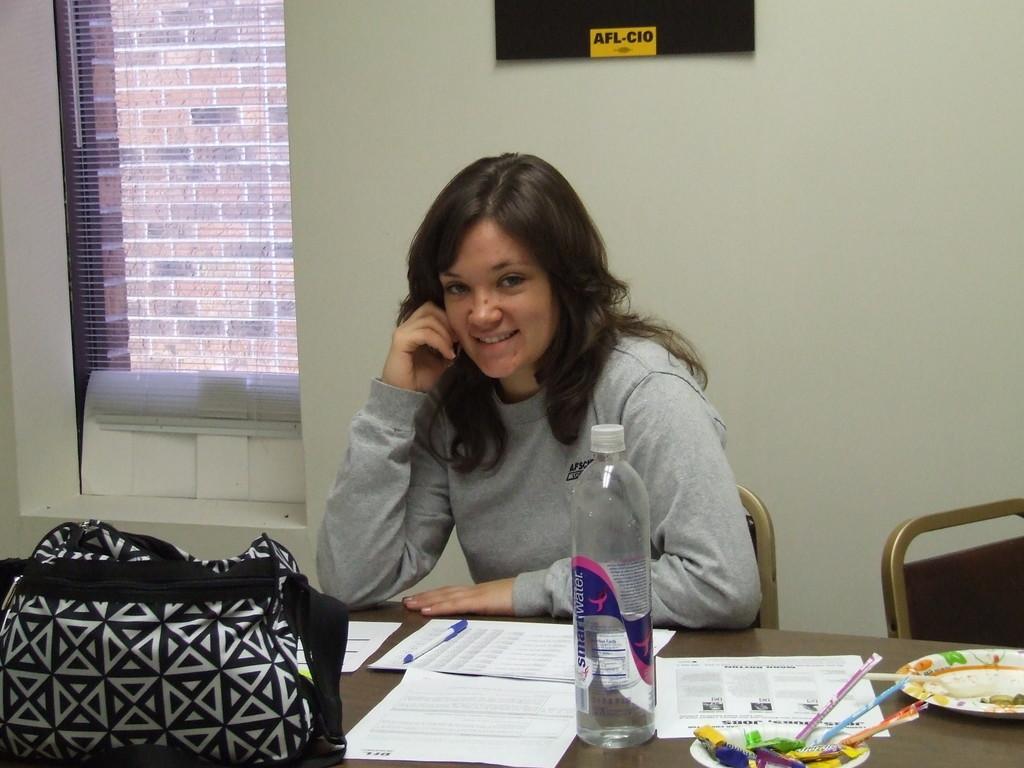How would you summarize this image in a sentence or two? In the middle of the image a woman is sitting on a chair and smiling. Bottom right side of the image there is a table on the table there are some papers, bag, pen, bottle and there are two plates. Behind her there is a wall. 